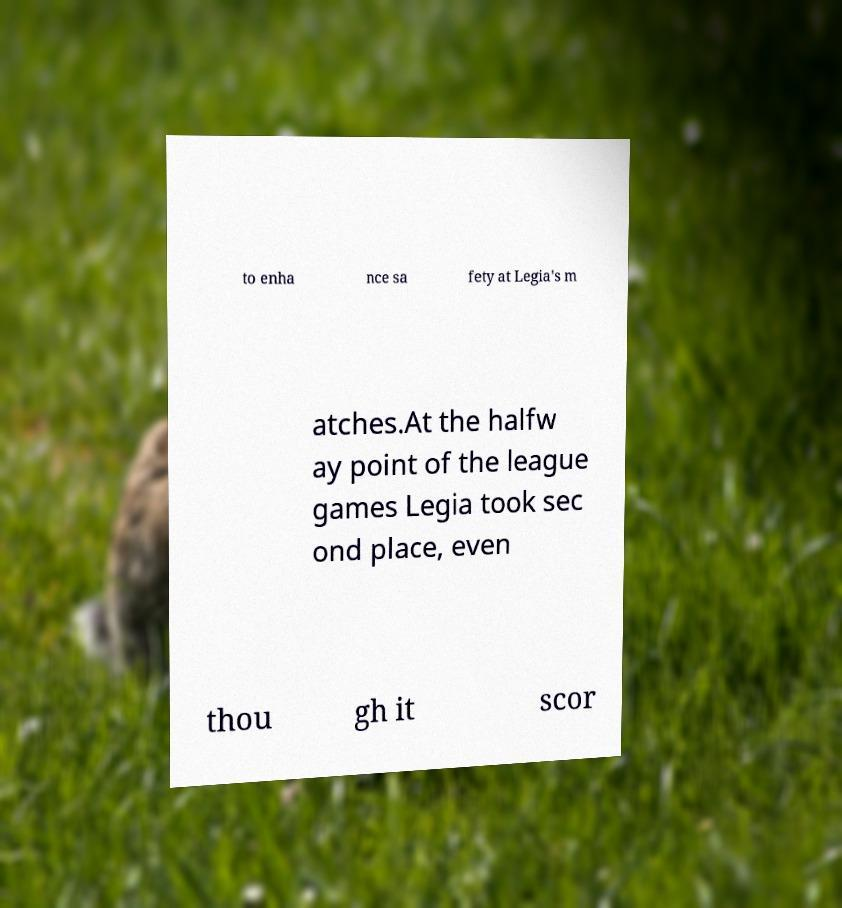Please identify and transcribe the text found in this image. to enha nce sa fety at Legia's m atches.At the halfw ay point of the league games Legia took sec ond place, even thou gh it scor 